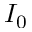<formula> <loc_0><loc_0><loc_500><loc_500>I _ { 0 }</formula> 